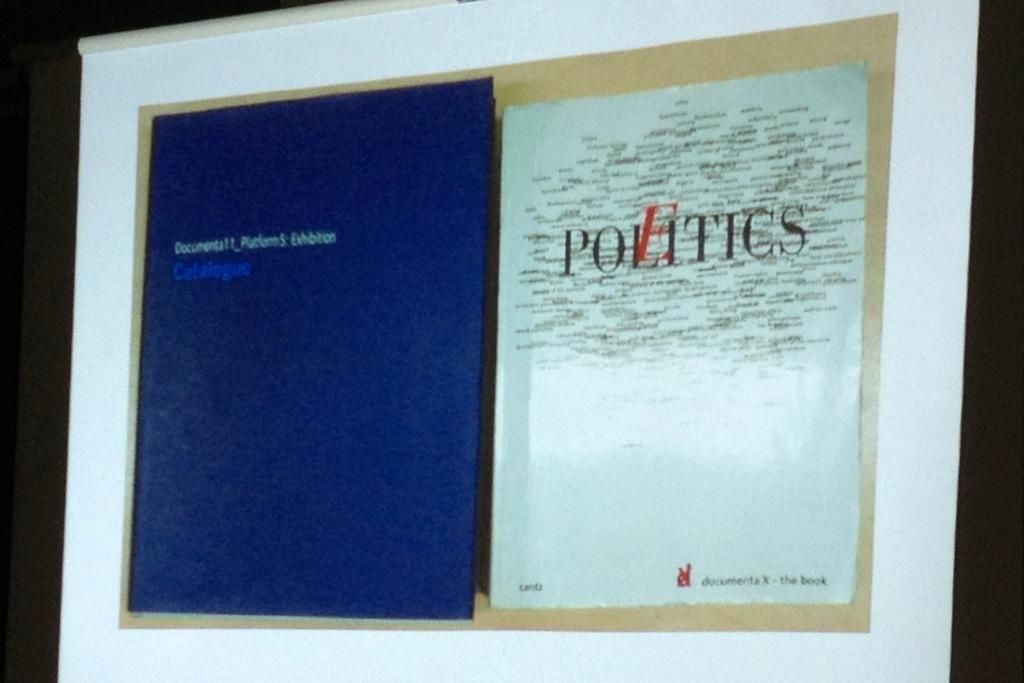<image>
Present a compact description of the photo's key features. A blue and a white poster on a wall, the white one reading Politics. 